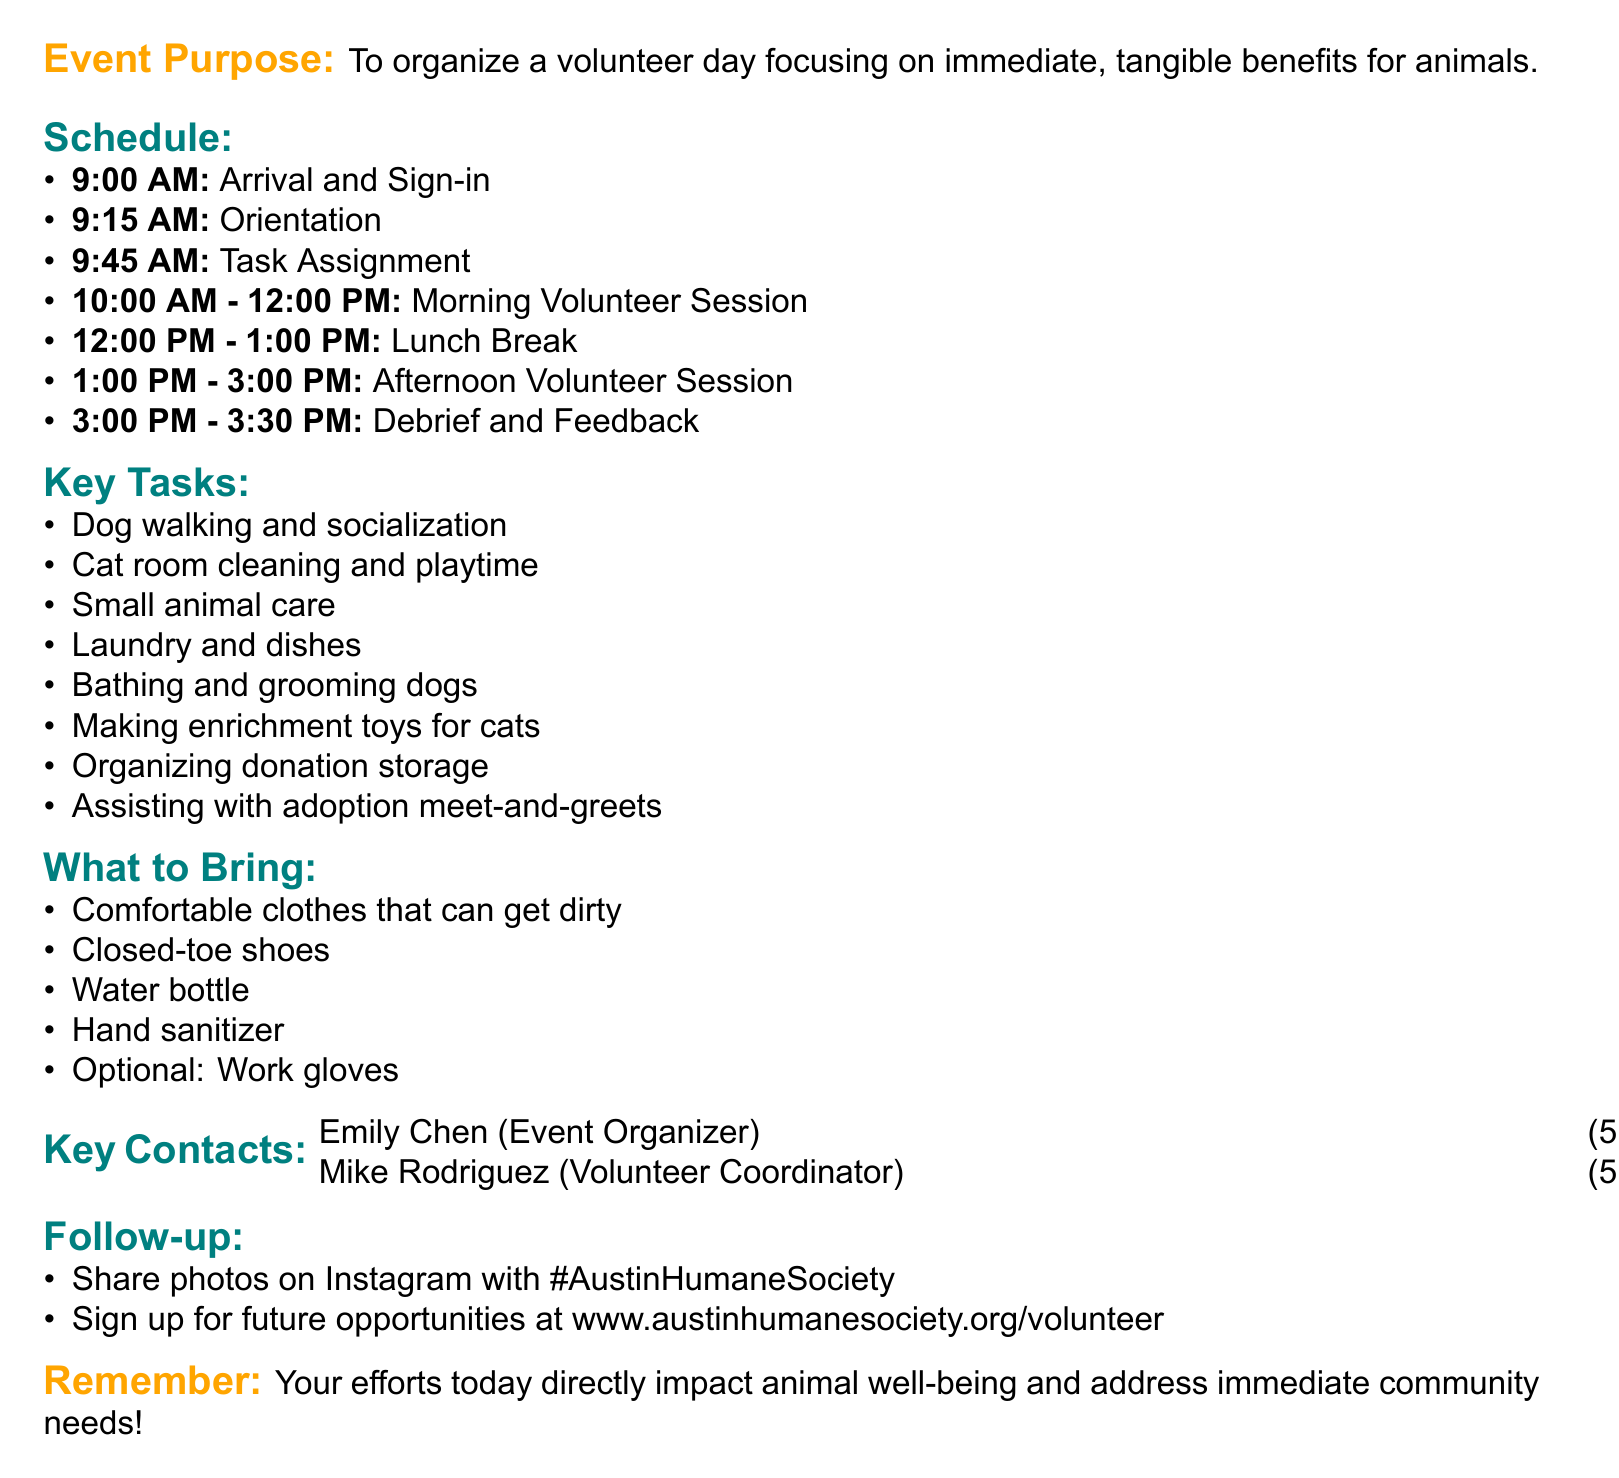what is the event title? The event title is stated at the top of the document.
Answer: Volunteer Day at the Humane Society of Austin when does the lunch break occur? The lunch break is mentioned in the schedule section of the document.
Answer: 12:00 PM - 1:00 PM who is the Event Organizer? The document lists key contacts where the Event Organizer’s name is provided.
Answer: Emily Chen how long is the morning volunteer session? The duration of the morning volunteer session is specified in the schedule section.
Answer: 2 hours what tasks will be done during the afternoon volunteer session? The afternoon volunteer session describes specific tasks to be performed.
Answer: Bathing and grooming dogs, making enrichment toys for cats, organizing donation storage, assisting with adoption meet-and-greets what are volunteers encouraged to share on social media? The follow-up activities suggest social media engagement specifics.
Answer: Photos what should volunteers wear? The materials needed section outlines what volunteers should wear.
Answer: Comfortable clothes that can get dirty how many hours of socialization are provided to animals? This is one of the metrics used to measure impact as mentioned in the document.
Answer: Hours of socialization provided to animals 